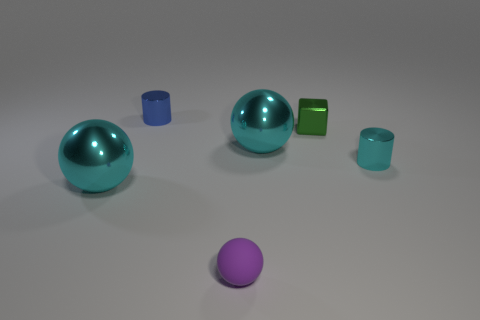Subtract all rubber balls. How many balls are left? 2 Add 3 large purple rubber objects. How many objects exist? 9 Subtract all cylinders. How many objects are left? 4 Add 5 small cubes. How many small cubes are left? 6 Add 1 big blue objects. How many big blue objects exist? 1 Subtract all cyan spheres. How many spheres are left? 1 Subtract 0 cyan cubes. How many objects are left? 6 Subtract 1 cubes. How many cubes are left? 0 Subtract all brown balls. Subtract all red blocks. How many balls are left? 3 Subtract all green cylinders. How many blue cubes are left? 0 